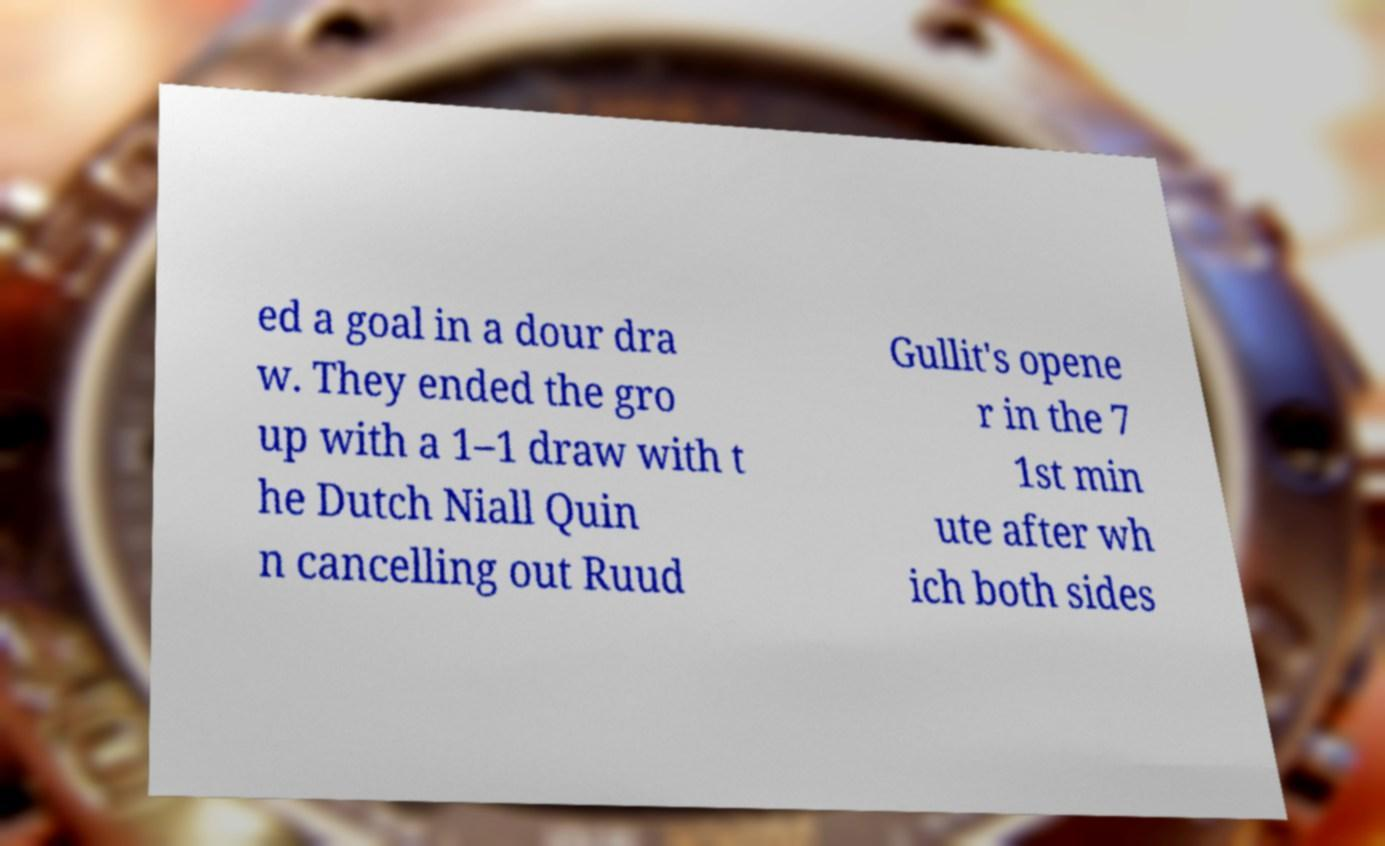I need the written content from this picture converted into text. Can you do that? ed a goal in a dour dra w. They ended the gro up with a 1–1 draw with t he Dutch Niall Quin n cancelling out Ruud Gullit's opene r in the 7 1st min ute after wh ich both sides 